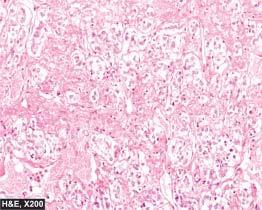what does the tumour have?
Answer the question using a single word or phrase. Typical zellballen or nested pattern 